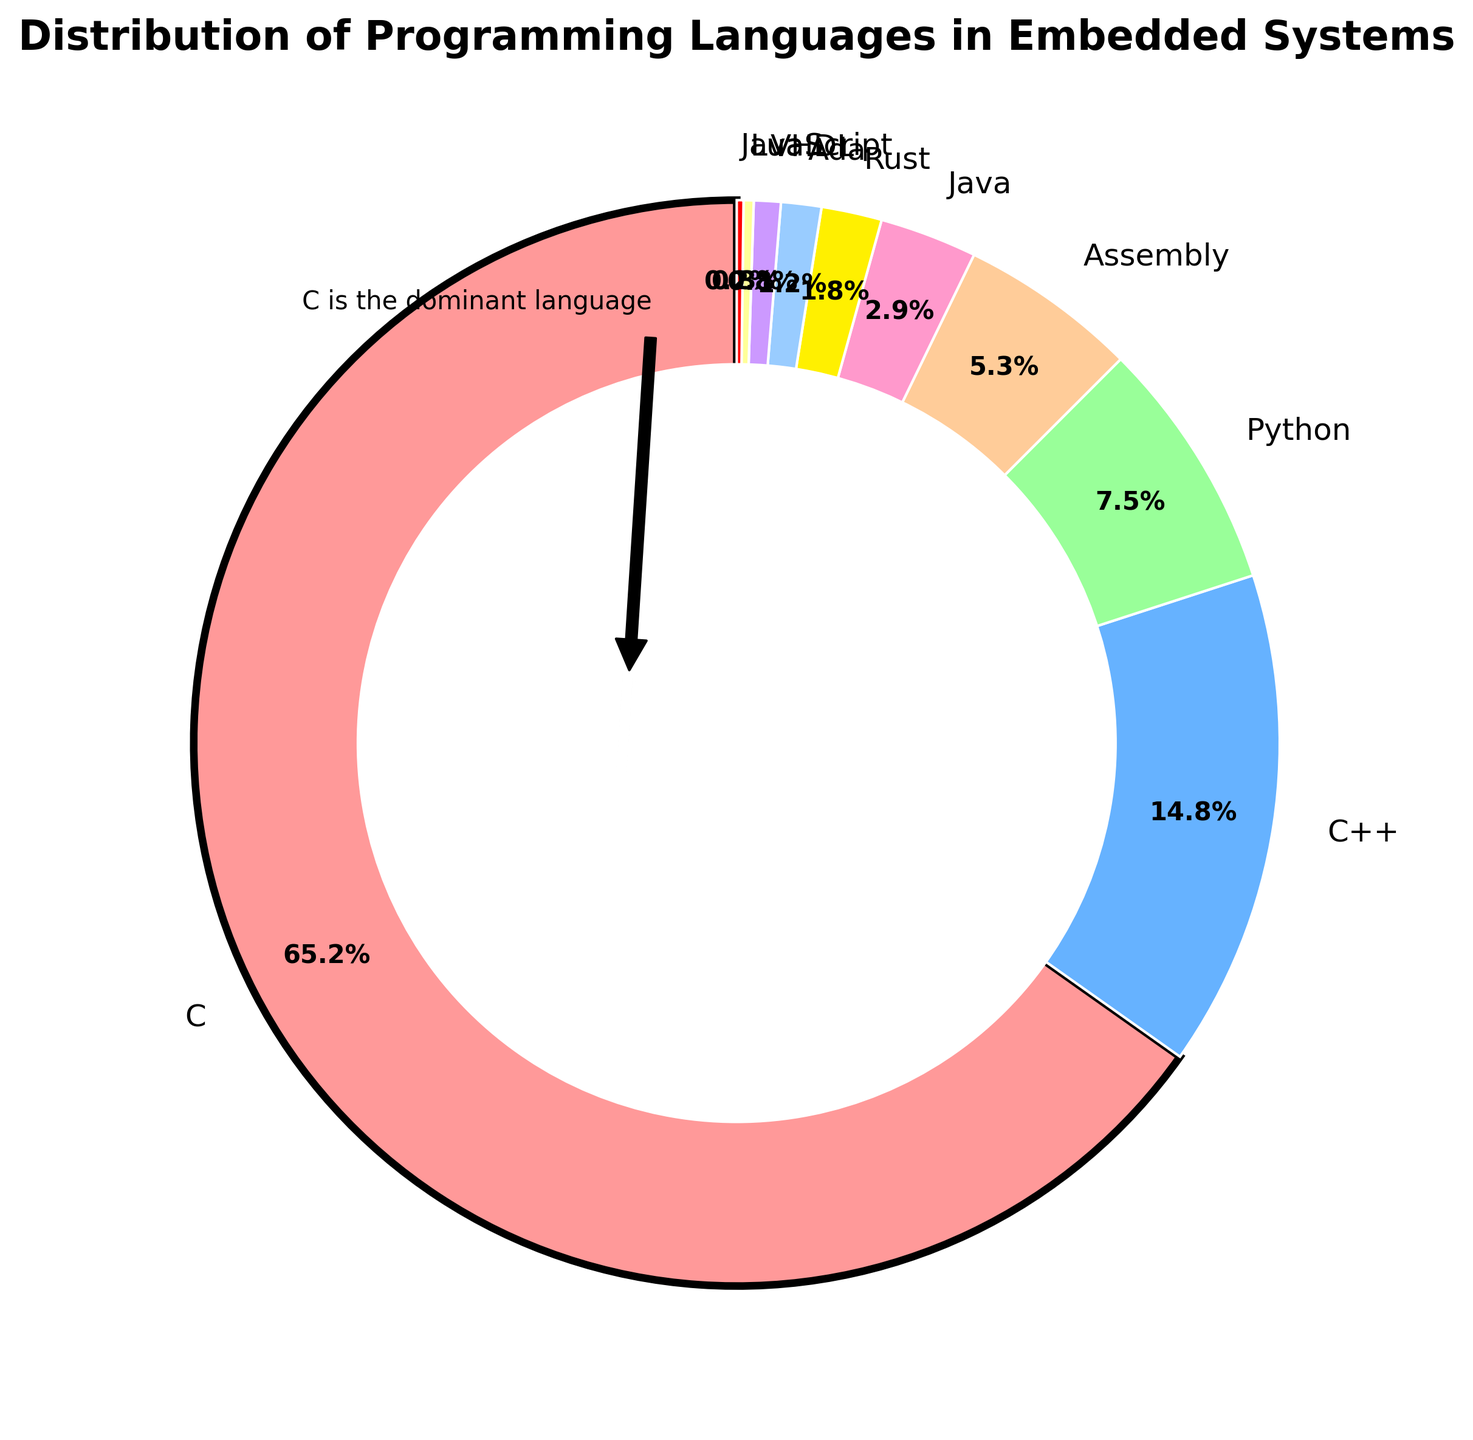What percentage of the total usage is held by languages other than C? First, identify the percentage of C, which is 65.2%. Subtract this percentage from 100% to determine the combined percentage of all other languages. So, 100 - 65.2 = 34.8%.
Answer: 34.8% Which language holds the second-largest share in embedded systems? By examining the pie chart, observe that C++ has the second-largest slice after C. According to the data, C++ is 14.8%.
Answer: C++ Which languages combined hold a greater percentage than C++? Identify percentages of other languages and sum them until exceeding C++ (14.8%). So, combining Python (7.5%), Assembly (5.3%), and Java (2.9%) yields 15.7%, which is greater than C++'s 14.8%.
Answer: Python, Assembly, and Java By how much is Python less utilized than C++ in embedded systems? Python has 7.5%, and C++ has 14.8%. Subtract the two to find the difference: 14.8 - 7.5 = 7.3%.
Answer: 7.3% How is C visually highlighted in the pie chart? Notice the visual emphasis on C. It has a distinct black border with a higher linewidth compared to other slices.
Answer: Black border with thicker linewidth What is the combined usage percentage of the bottom four languages in the chart? Sum the percentages of Rust (1.8%), Ada (1.2%), VHDL (0.8%), Lua (0.3%), and JavaScript (0.2%): 1.8 + 1.2 + 0.8 + 0.3 + 0.2 = 4.3%.
Answer: 4.3% What is the proportion of non-C languages compared to C in terms of visual area? From previous calculations, non-C languages collectively make up 34.8%. Since C represents 65.2%, the ratio of non-C to C is 34.8 to 65.2 or simplified, approximately 1 to 1.87.
Answer: Approximately 1:1.87 Among Assembly and Java, which language has a smaller share and by how much? From the chart, Assembly has 5.3%, and Java has 2.9%. Subtract Java's percentage from Assembly's: 5.3 - 2.9 = 2.4%.
Answer: Java by 2.4% How does the visualization indicate the dominance of C? The annotation 'C is the dominant language' points towards C's slice, emphasizing its prominence. Moreover, its substantial size noticeably outweighs other slices.
Answer: Annotation and larger slice size Which language has the closest usage percentage to 1%, and what is its exact percentage? Examine the percentages around 1%. Ada is closest with 1.2%.
Answer: Ada, 1.2% 